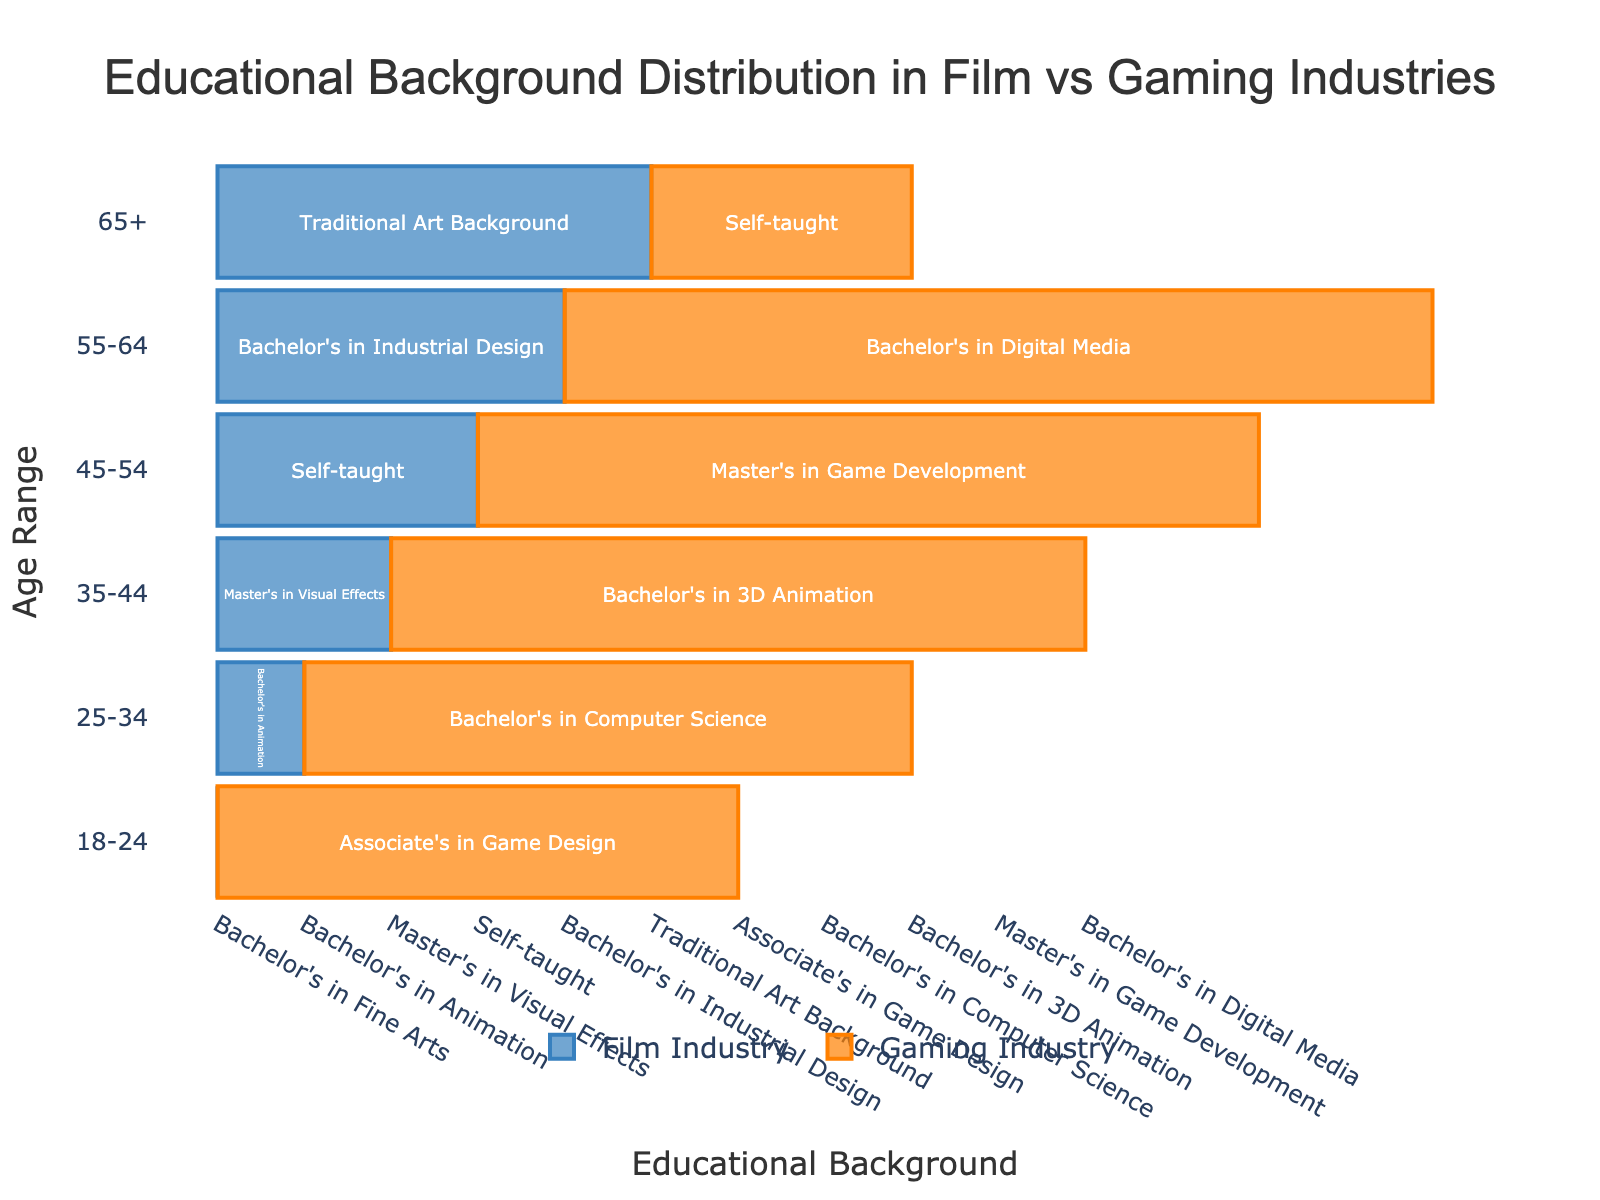What's the title of the figure? The title is shown at the top of the figure. It provides a summary of what the chart represents. The title reads "Educational Background Distribution in Film vs Gaming Industries".
Answer: Educational Background Distribution in Film vs Gaming Industries What is the educational background of 3D modelers aged 18-24 in the gaming industry? This can be seen by looking at the bar corresponding to the 18-24 age range on the gaming industry side of the pyramid. The text inside the bar reads "Associate's in Game Design".
Answer: Associate's in Game Design Which industry has more diverse educational backgrounds across age ranges? To determine diversity, we can compare the variety of educational backgrounds listed for each industry. The film industry has a varied set including Fine Arts, Animation, Visual Effects, Self-taught, Industrial Design, and Traditional Art Background. The gaming industry presents backgrounds in Game Design, Computer Science, 3D Animation, Game Development, Digital Media, and Self-taught. Both industries display similar diversity with unique fields specific to their focus.
Answer: Similar diversity For the age range 35-44, what is the difference between the educational backgrounds in the film and gaming industries? Look at the 35-44 age range on both sides of the pyramid. The film industry shows "Master's in Visual Effects" while the gaming industry shows "Bachelor's in 3D Animation". The difference lies in the specific focus and the degree level, with the film industry having a master's degree and the gaming industry having a bachelor's.
Answer: Master's in Visual Effects vs. Bachelor's in 3D Animation What educational background is shared across multiple age ranges within the same industry? Assess each industry's educational background across all age ranges. For the film industry, each age range has a unique educational background. In contrast, the gaming industry repeats "Self-taught" in the 45-54 and 65+ age ranges.
Answer: Self-taught in the gaming industry What age range has the most advanced educational background in the film industry? Advanced educational background often implies higher degrees like a master's. By examining each age range, the 35-44 range in the film industry has "Master's in Visual Effects", which is the most advanced among all.
Answer: 35-44 Which industry has a greater emphasis on self-taught 3D modelers in the older age ranges? Look specifically at the educational background for older age ranges (45-54 and 65+). In the gaming industry, "Self-taught" appears in these older age ranges while the film industry only has "Self-taught" in the 45-54 range.
Answer: Gaming industry How many different educational backgrounds are listed for the film industry? Count the distinct educational backgrounds for the film industry mentioned in each age range. They include Fine Arts, Animation, Visual Effects, Self-taught, Industrial Design, and Traditional Art Background, making a total of six.
Answer: 6 What pattern can be observed regarding the level of formal education in 3D modelers as they age in the gaming industry? By looking at each age range, we can observe that the younger age ranges start with more formal, recent degrees (e.g., Associate's, Bachelor's), while older age ranges like 45-54 and 65+ increasingly include "Self-taught" backgrounds. This indicates a decreasing reliance on formal education as the age range increases.
Answer: Decreasing reliance on formal education as age increases 